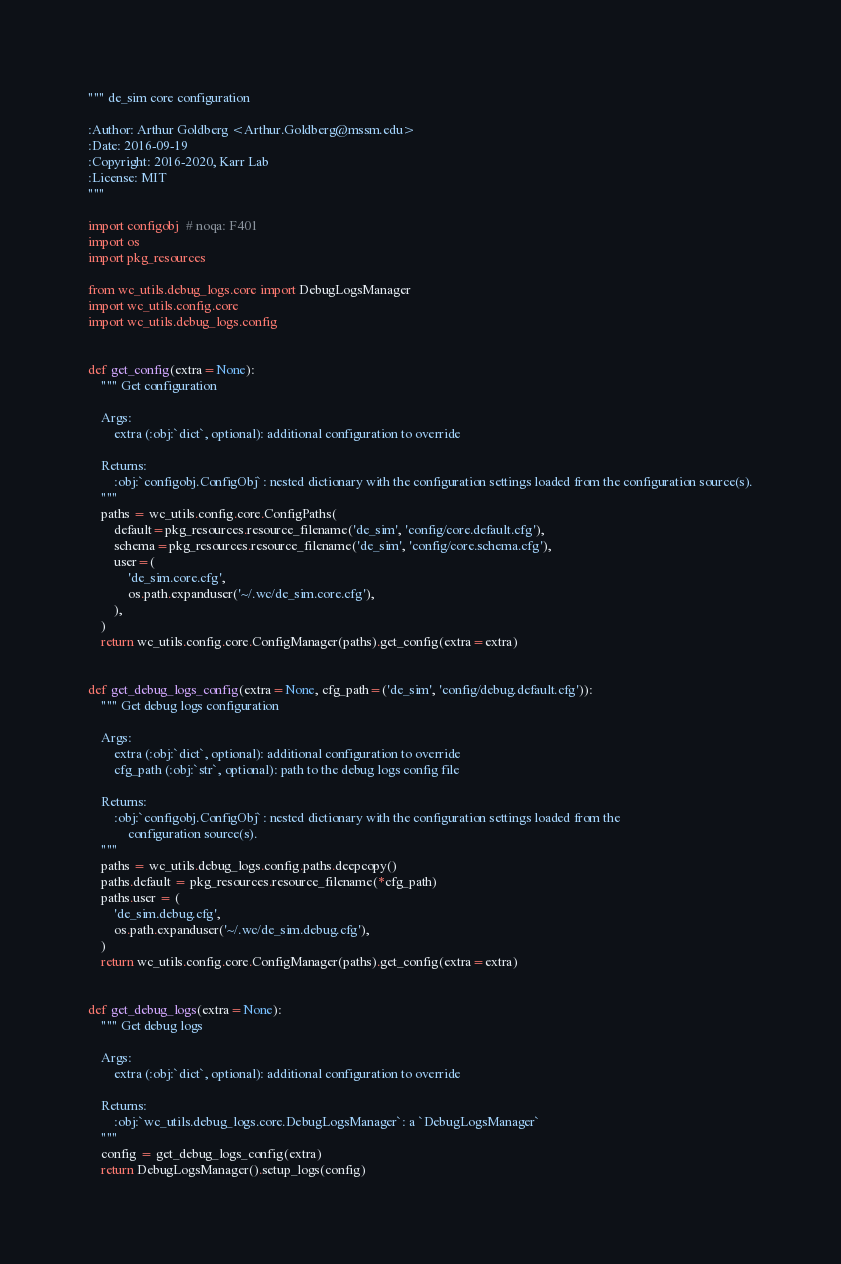<code> <loc_0><loc_0><loc_500><loc_500><_Python_>""" de_sim core configuration

:Author: Arthur Goldberg <Arthur.Goldberg@mssm.edu>
:Date: 2016-09-19
:Copyright: 2016-2020, Karr Lab
:License: MIT
"""

import configobj  # noqa: F401
import os
import pkg_resources

from wc_utils.debug_logs.core import DebugLogsManager
import wc_utils.config.core
import wc_utils.debug_logs.config


def get_config(extra=None):
    """ Get configuration

    Args:
        extra (:obj:`dict`, optional): additional configuration to override

    Returns:
        :obj:`configobj.ConfigObj`: nested dictionary with the configuration settings loaded from the configuration source(s).
    """
    paths = wc_utils.config.core.ConfigPaths(
        default=pkg_resources.resource_filename('de_sim', 'config/core.default.cfg'),
        schema=pkg_resources.resource_filename('de_sim', 'config/core.schema.cfg'),
        user=(
            'de_sim.core.cfg',
            os.path.expanduser('~/.wc/de_sim.core.cfg'),
        ),
    )
    return wc_utils.config.core.ConfigManager(paths).get_config(extra=extra)


def get_debug_logs_config(extra=None, cfg_path=('de_sim', 'config/debug.default.cfg')):
    """ Get debug logs configuration

    Args:
        extra (:obj:`dict`, optional): additional configuration to override
        cfg_path (:obj:`str`, optional): path to the debug logs config file

    Returns:
        :obj:`configobj.ConfigObj`: nested dictionary with the configuration settings loaded from the
            configuration source(s).
    """
    paths = wc_utils.debug_logs.config.paths.deepcopy()
    paths.default = pkg_resources.resource_filename(*cfg_path)
    paths.user = (
        'de_sim.debug.cfg',
        os.path.expanduser('~/.wc/de_sim.debug.cfg'),
    )
    return wc_utils.config.core.ConfigManager(paths).get_config(extra=extra)


def get_debug_logs(extra=None):
    """ Get debug logs

    Args:
        extra (:obj:`dict`, optional): additional configuration to override

    Returns:
        :obj:`wc_utils.debug_logs.core.DebugLogsManager`: a `DebugLogsManager`
    """
    config = get_debug_logs_config(extra)
    return DebugLogsManager().setup_logs(config)
</code> 